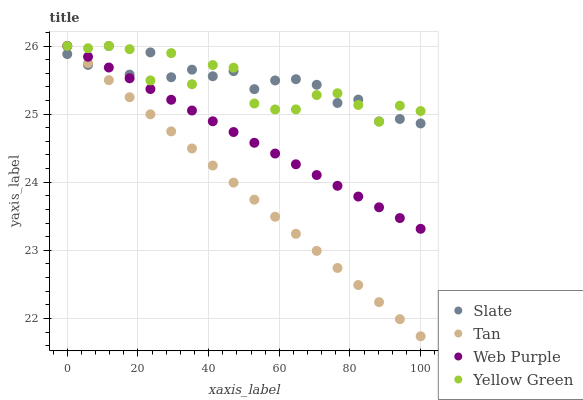Does Tan have the minimum area under the curve?
Answer yes or no. Yes. Does Slate have the maximum area under the curve?
Answer yes or no. Yes. Does Slate have the minimum area under the curve?
Answer yes or no. No. Does Tan have the maximum area under the curve?
Answer yes or no. No. Is Web Purple the smoothest?
Answer yes or no. Yes. Is Yellow Green the roughest?
Answer yes or no. Yes. Is Slate the smoothest?
Answer yes or no. No. Is Slate the roughest?
Answer yes or no. No. Does Tan have the lowest value?
Answer yes or no. Yes. Does Slate have the lowest value?
Answer yes or no. No. Does Yellow Green have the highest value?
Answer yes or no. Yes. Does Tan intersect Slate?
Answer yes or no. Yes. Is Tan less than Slate?
Answer yes or no. No. Is Tan greater than Slate?
Answer yes or no. No. 